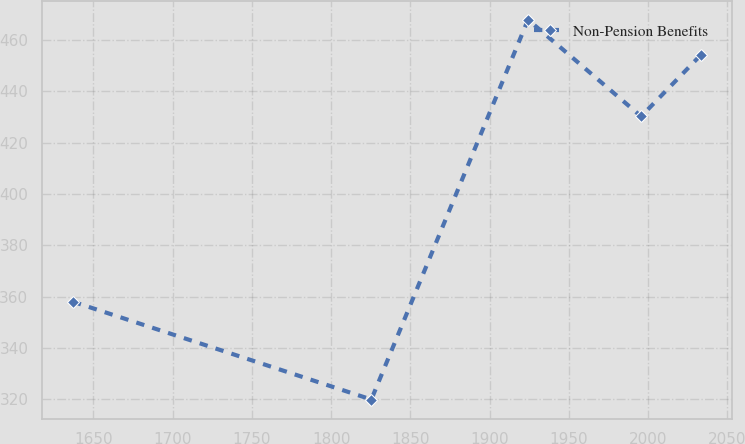Convert chart. <chart><loc_0><loc_0><loc_500><loc_500><line_chart><ecel><fcel>Non-Pension Benefits<nl><fcel>1637.18<fcel>358.04<nl><fcel>1825.39<fcel>319.96<nl><fcel>1924.26<fcel>467.9<nl><fcel>1995.6<fcel>430.23<nl><fcel>2033.27<fcel>454.17<nl></chart> 